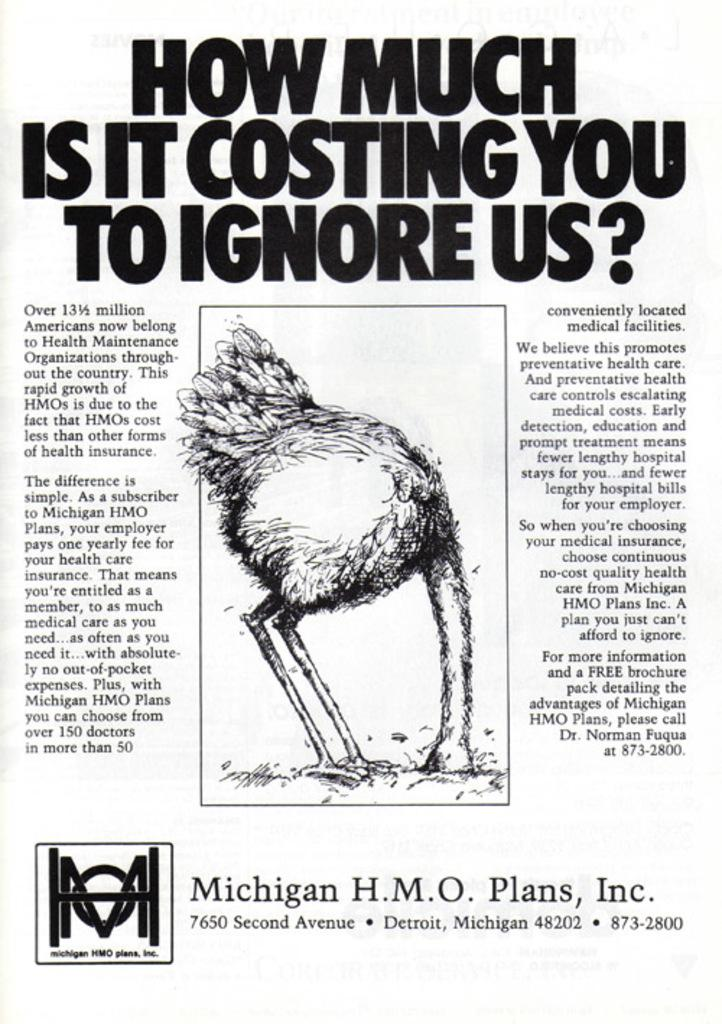What is the medium of the image? The image is a printed paper. What can be found on the printed paper? There is text and a picture of a bird on the paper. What type of metal is visible in the image? There is no metal present in the image; it is a printed paper with text and a picture of a bird. Can you describe the ocean in the image? There is no ocean present in the image; it is a printed paper with text and a picture of a bird. 